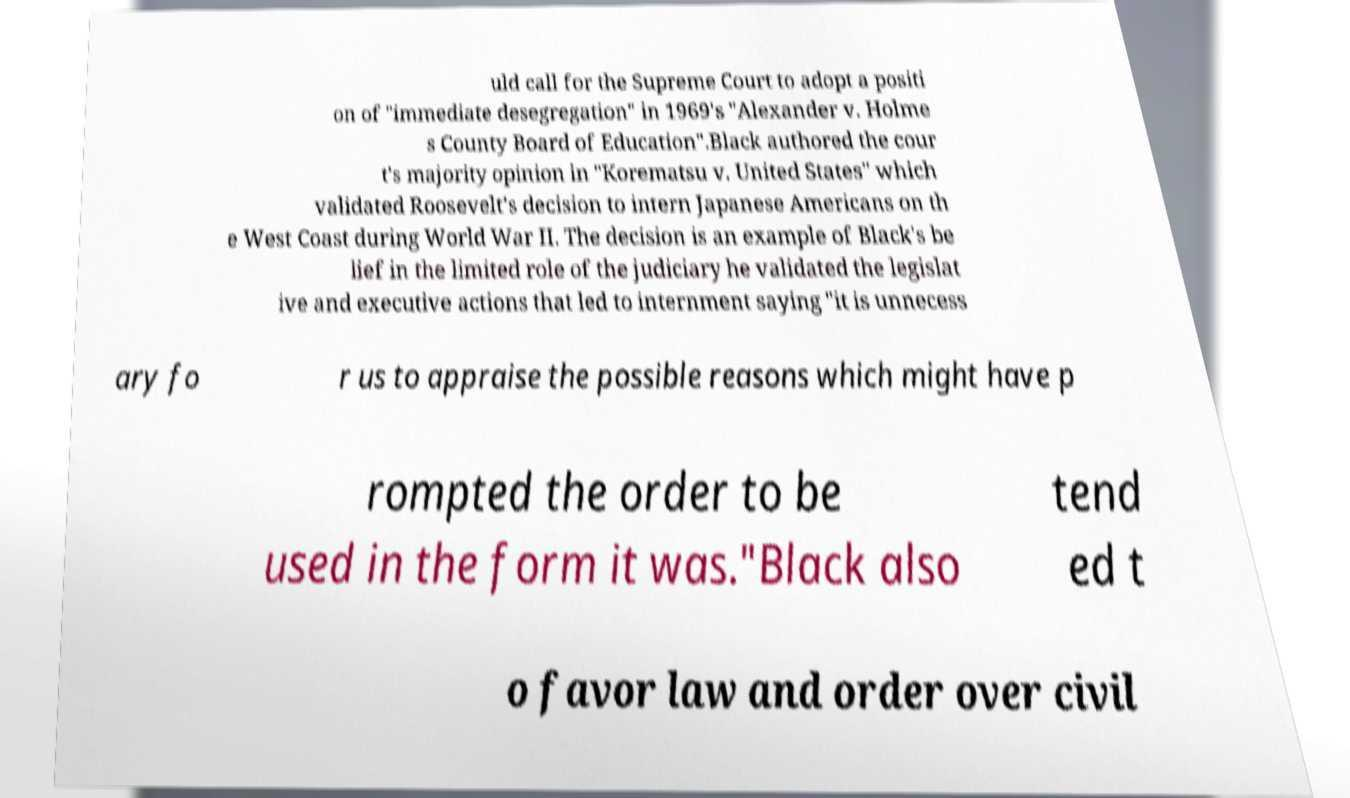Please identify and transcribe the text found in this image. uld call for the Supreme Court to adopt a positi on of "immediate desegregation" in 1969's "Alexander v. Holme s County Board of Education".Black authored the cour t's majority opinion in "Korematsu v. United States" which validated Roosevelt's decision to intern Japanese Americans on th e West Coast during World War II. The decision is an example of Black's be lief in the limited role of the judiciary he validated the legislat ive and executive actions that led to internment saying "it is unnecess ary fo r us to appraise the possible reasons which might have p rompted the order to be used in the form it was."Black also tend ed t o favor law and order over civil 